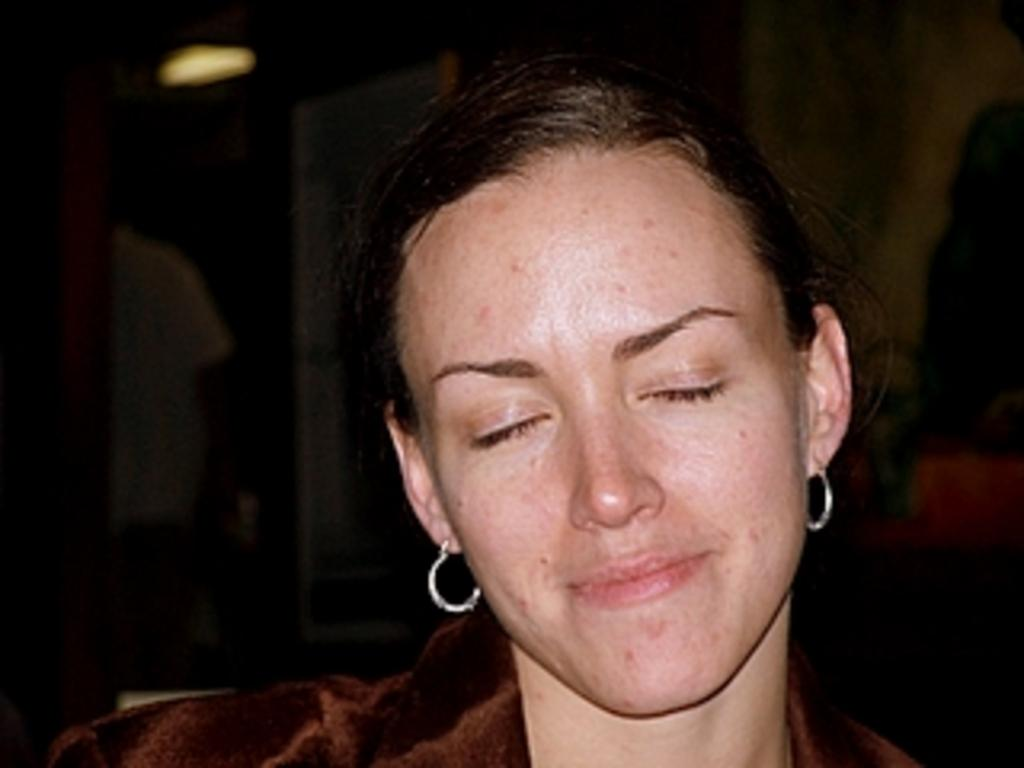Who is present in the image? There is a woman in the image. What is the woman doing in the image? The woman is sitting on a chair in the image. Can you describe the lighting in the image? There is light in the image. What can be seen in the background of the image? There is a wall in the image, and the background is dark. What type of spot can be seen on the woman's shirt in the image? There is no spot visible on the woman's shirt in the image. Can you read the note that the woman is holding in the image? There is no note present in the image. 